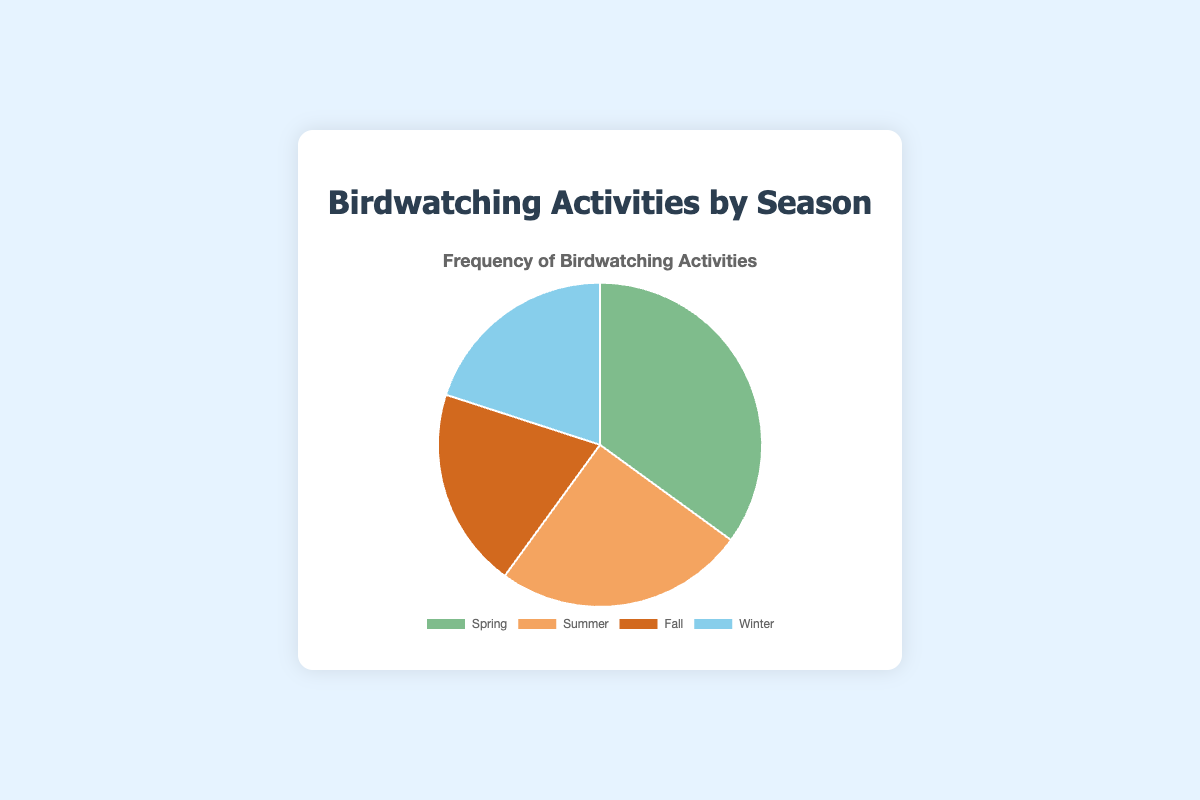Which season has the highest frequency of birdwatching activities? The segment representing "Spring" covers the largest area on the pie chart, indicating the highest frequency of birdwatching activities.
Answer: Spring How much higher is the birdwatching frequency in Spring compared to Summer? The frequency for Spring is 35 and for Summer is 25. The difference is 35 - 25.
Answer: 10 What's the combined percentage of birdwatching activities in Fall and Winter? Both Fall and Winter have frequencies of 20 each. The total frequency is 20 + 20 = 40, which is 40/100 = 40% of the pie chart.
Answer: 40% Which two seasons have equal birdwatching frequencies? By looking at the sizes of the segments, "Fall" and "Winter" both have 20, so their frequencies are equal.
Answer: Fall and Winter What is the ratio of birdwatching frequency between Spring and Fall? The frequency for Spring is 35 and for Fall is 20. The ratio is 35:20, which simplifies to 7:4.
Answer: 7:4 Which season occupies approximately one-third of the pie chart? The segment for Spring represents the highest frequency (35%), which is closest to one-third of the total 100%.
Answer: Spring How does the summer birdwatching frequency compare visually to winter? The segment for Summer is slightly larger than Winter, indicating more frequency but by a smaller margin compared to Spring and other seasons.
Answer: Larger If you were to visually divide the chart into halves, would any season align closely with the halfway mark? Spring covers about 35%, and no single segment is close to 50%. The combined 40% of Fall and Winter almost reaches but not exactly half.
Answer: No What is the total frequency of birdwatching activities for the three lower-frequency seasons? The frequencies for Summer, Fall, and Winter are 25, 20, and 20 respectively. The total is 25 + 20 + 20 = 65.
Answer: 65 